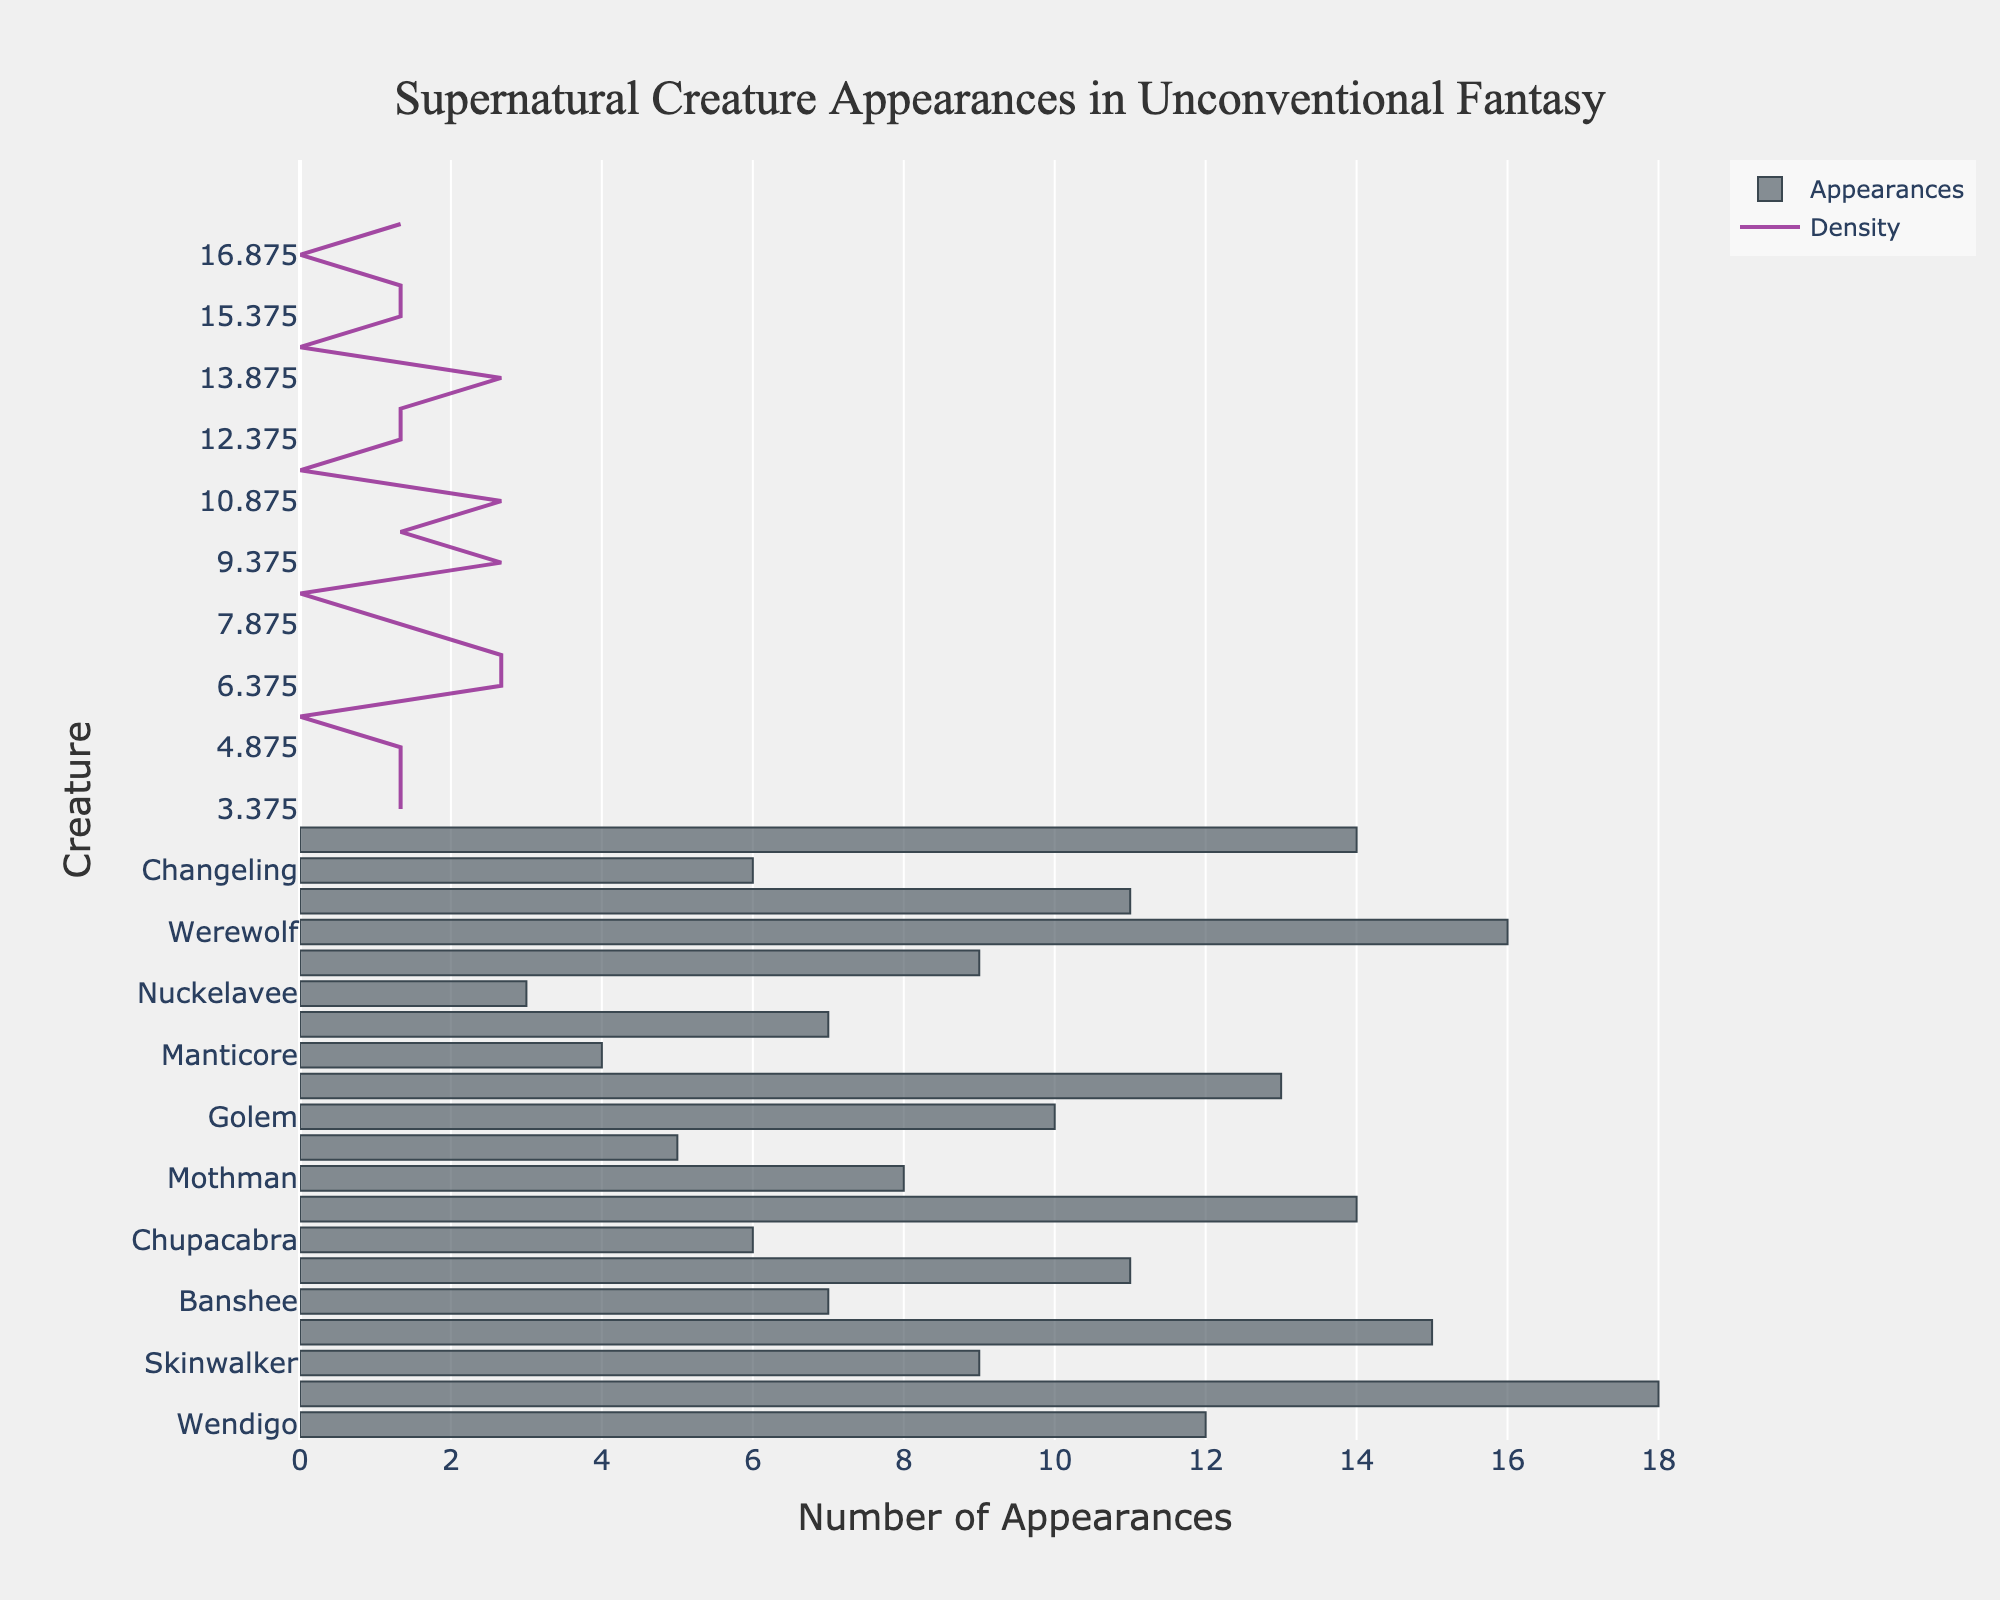What is the title of the plot? The title of the plot is typically displayed prominently at the top of the figure. In this case, it reads "Supernatural Creature Appearances in Unconventional Fantasy."
Answer: Supernatural Creature Appearances in Unconventional Fantasy Which supernatural creature has the highest frequency of appearances? To identify the creature with the highest frequency, observe the histogram bars. The creature with the tallest bar represents the highest frequency. In this case, "Shadow People" has the highest frequency of 18 appearances.
Answer: Shadow People What is the total number of creature appearances recorded in the data? To find the total number of appearances, sum the appearances of all listed creatures: 12+18+9+15+7+11+6+14+8+5+10+13+4+7+3+9+16+11+6+14 = 198.
Answer: 198 Which creatures appear more frequently than Hellhound? Observe the data points and find those with frequencies greater than Hellhound's (14 appearances). These creatures are Shadow People (18) and Werewolf (16).
Answer: Shadow People, Werewolf What is the average frequency of creature appearances? To find the average frequency, sum all appearances and divide by the number of creatures: (198 total appearances) / 20 creatures = 9.9.
Answer: 9.9 Which creature has the lowest frequency of appearances, and how many appearances is that? The creature with the shortest bar in the histogram represents the lowest frequency. The "Nuckelavee" has the lowest frequency with 3 appearances.
Answer: Nuckelavee, 3 How many creatures have an appearance frequency of 10 or more? Count the number of creatures whose appearance frequencies are 10 or higher. These creatures are Wendigo, Shadow People, Eldritch Horror, Doppelganger, Hellhound, Kraken, Werewolf, Ghoul, and Wraith. There are 9 such creatures.
Answer: 9 What is the most common range of appearances as shown by the KDE curve? The KDE curve shows the density of appearances. The highest peak of the KDE curve indicates the most common range, which is around 10-14 appearances.
Answer: 10-14 appearances Compare the appearances of Banshee and Chupacabra. Which one appears more frequently? Refer to the histogram to compare the heights of the bars for Banshee (7 appearances) and Chupacabra (6 appearances). Banshee appears more frequently.
Answer: Banshee What is the sum of the appearances for all creatures with “horror” elements in their names? Add the number of appearances of Eldritch Horror (15) and Wraith (14): 15 + 14 = 29.
Answer: 29 